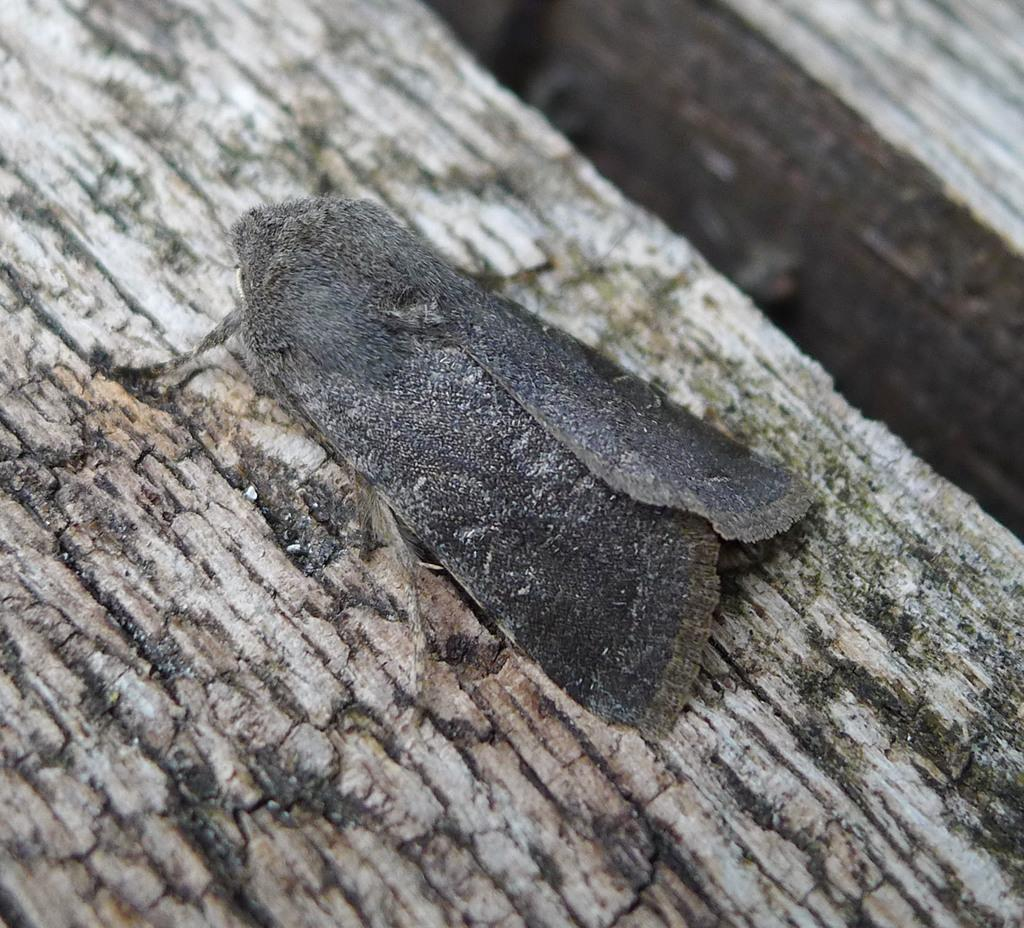What type of creature can be seen in the image? There is an insect in the image. Where is the insect located? The insect is on a wooden surface. What type of vest is the insect wearing in the image? There is no vest present in the image, as insects do not wear clothing. 